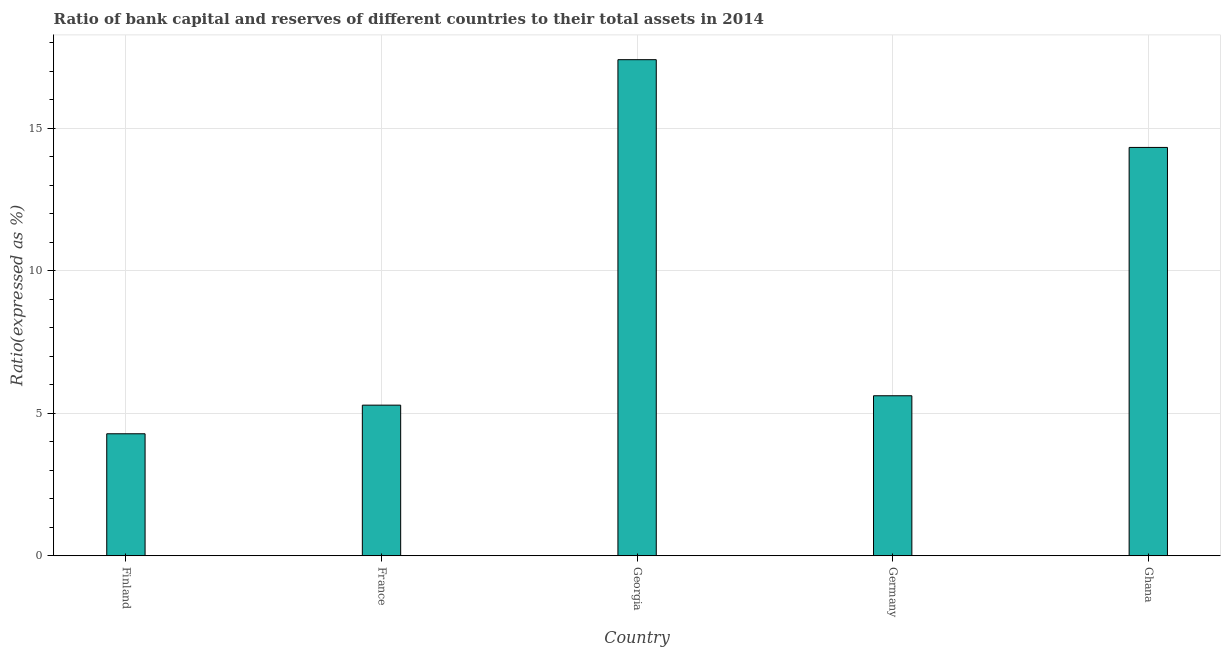Does the graph contain grids?
Your response must be concise. Yes. What is the title of the graph?
Make the answer very short. Ratio of bank capital and reserves of different countries to their total assets in 2014. What is the label or title of the Y-axis?
Your response must be concise. Ratio(expressed as %). What is the bank capital to assets ratio in Ghana?
Offer a very short reply. 14.32. Across all countries, what is the maximum bank capital to assets ratio?
Offer a terse response. 17.4. Across all countries, what is the minimum bank capital to assets ratio?
Offer a very short reply. 4.28. In which country was the bank capital to assets ratio maximum?
Offer a very short reply. Georgia. In which country was the bank capital to assets ratio minimum?
Your response must be concise. Finland. What is the sum of the bank capital to assets ratio?
Your answer should be compact. 46.89. What is the difference between the bank capital to assets ratio in Germany and Ghana?
Provide a short and direct response. -8.71. What is the average bank capital to assets ratio per country?
Keep it short and to the point. 9.38. What is the median bank capital to assets ratio?
Your answer should be very brief. 5.61. What is the ratio of the bank capital to assets ratio in Finland to that in Georgia?
Provide a short and direct response. 0.25. Is the bank capital to assets ratio in Finland less than that in Ghana?
Your answer should be very brief. Yes. Is the difference between the bank capital to assets ratio in France and Georgia greater than the difference between any two countries?
Keep it short and to the point. No. What is the difference between the highest and the second highest bank capital to assets ratio?
Make the answer very short. 3.08. Is the sum of the bank capital to assets ratio in Georgia and Ghana greater than the maximum bank capital to assets ratio across all countries?
Offer a very short reply. Yes. What is the difference between the highest and the lowest bank capital to assets ratio?
Your response must be concise. 13.12. In how many countries, is the bank capital to assets ratio greater than the average bank capital to assets ratio taken over all countries?
Ensure brevity in your answer.  2. What is the difference between two consecutive major ticks on the Y-axis?
Provide a short and direct response. 5. What is the Ratio(expressed as %) in Finland?
Offer a terse response. 4.28. What is the Ratio(expressed as %) of France?
Offer a terse response. 5.28. What is the Ratio(expressed as %) of Georgia?
Offer a very short reply. 17.4. What is the Ratio(expressed as %) of Germany?
Your answer should be compact. 5.61. What is the Ratio(expressed as %) of Ghana?
Give a very brief answer. 14.32. What is the difference between the Ratio(expressed as %) in Finland and France?
Provide a short and direct response. -1. What is the difference between the Ratio(expressed as %) in Finland and Georgia?
Provide a succinct answer. -13.12. What is the difference between the Ratio(expressed as %) in Finland and Germany?
Your response must be concise. -1.33. What is the difference between the Ratio(expressed as %) in Finland and Ghana?
Offer a very short reply. -10.04. What is the difference between the Ratio(expressed as %) in France and Georgia?
Keep it short and to the point. -12.11. What is the difference between the Ratio(expressed as %) in France and Germany?
Offer a very short reply. -0.33. What is the difference between the Ratio(expressed as %) in France and Ghana?
Your response must be concise. -9.04. What is the difference between the Ratio(expressed as %) in Georgia and Germany?
Give a very brief answer. 11.78. What is the difference between the Ratio(expressed as %) in Georgia and Ghana?
Make the answer very short. 3.08. What is the difference between the Ratio(expressed as %) in Germany and Ghana?
Keep it short and to the point. -8.71. What is the ratio of the Ratio(expressed as %) in Finland to that in France?
Your answer should be compact. 0.81. What is the ratio of the Ratio(expressed as %) in Finland to that in Georgia?
Provide a short and direct response. 0.25. What is the ratio of the Ratio(expressed as %) in Finland to that in Germany?
Ensure brevity in your answer.  0.76. What is the ratio of the Ratio(expressed as %) in Finland to that in Ghana?
Keep it short and to the point. 0.3. What is the ratio of the Ratio(expressed as %) in France to that in Georgia?
Your response must be concise. 0.3. What is the ratio of the Ratio(expressed as %) in France to that in Germany?
Make the answer very short. 0.94. What is the ratio of the Ratio(expressed as %) in France to that in Ghana?
Offer a very short reply. 0.37. What is the ratio of the Ratio(expressed as %) in Georgia to that in Ghana?
Provide a short and direct response. 1.22. What is the ratio of the Ratio(expressed as %) in Germany to that in Ghana?
Your answer should be compact. 0.39. 